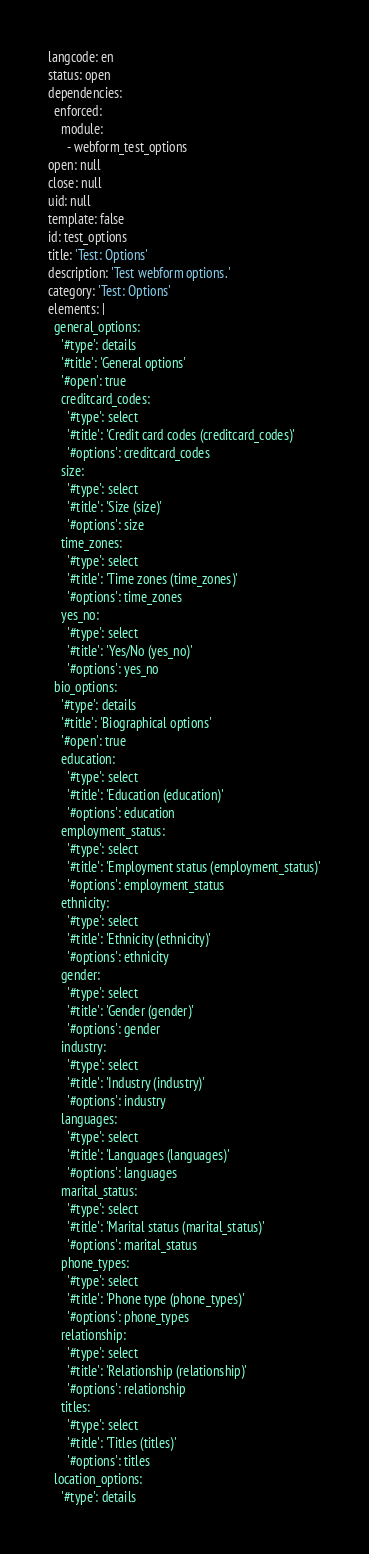<code> <loc_0><loc_0><loc_500><loc_500><_YAML_>langcode: en
status: open
dependencies:
  enforced:
    module:
      - webform_test_options
open: null
close: null
uid: null
template: false
id: test_options
title: 'Test: Options'
description: 'Test webform options.'
category: 'Test: Options'
elements: |
  general_options:
    '#type': details
    '#title': 'General options'
    '#open': true
    creditcard_codes:
      '#type': select
      '#title': 'Credit card codes (creditcard_codes)'
      '#options': creditcard_codes
    size:
      '#type': select
      '#title': 'Size (size)'
      '#options': size
    time_zones:
      '#type': select
      '#title': 'Time zones (time_zones)'
      '#options': time_zones
    yes_no:
      '#type': select
      '#title': 'Yes/No (yes_no)'
      '#options': yes_no
  bio_options:
    '#type': details
    '#title': 'Biographical options'
    '#open': true
    education:
      '#type': select
      '#title': 'Education (education)'
      '#options': education
    employment_status:
      '#type': select
      '#title': 'Employment status (employment_status)'
      '#options': employment_status
    ethnicity:
      '#type': select
      '#title': 'Ethnicity (ethnicity)'
      '#options': ethnicity
    gender:
      '#type': select
      '#title': 'Gender (gender)'
      '#options': gender
    industry:
      '#type': select
      '#title': 'Industry (industry)'
      '#options': industry
    languages:
      '#type': select
      '#title': 'Languages (languages)'
      '#options': languages
    marital_status:
      '#type': select
      '#title': 'Marital status (marital_status)'
      '#options': marital_status
    phone_types:
      '#type': select
      '#title': 'Phone type (phone_types)'
      '#options': phone_types
    relationship:
      '#type': select
      '#title': 'Relationship (relationship)'
      '#options': relationship
    titles:
      '#type': select
      '#title': 'Titles (titles)'
      '#options': titles
  location_options:
    '#type': details</code> 